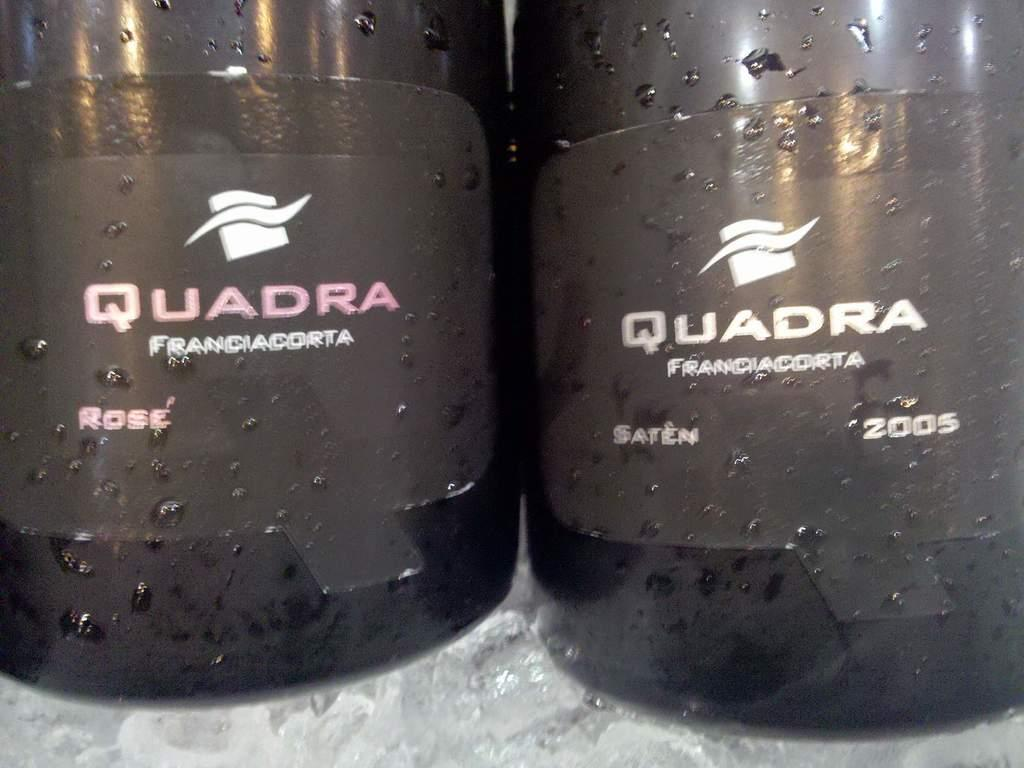Provide a one-sentence caption for the provided image. Two bottles of a rose and saten wine made by Quadra, one made in 2005. 